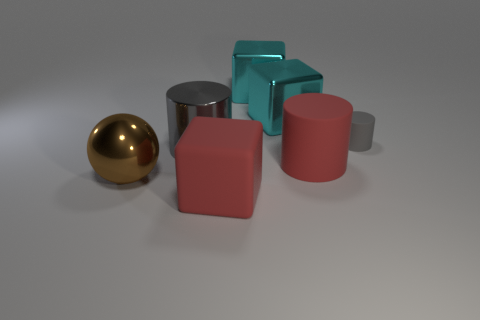Subtract 1 cylinders. How many cylinders are left? 2 Subtract all red balls. How many cyan blocks are left? 2 Subtract all big metal blocks. How many blocks are left? 1 Add 1 small cyan metallic spheres. How many objects exist? 8 Subtract all purple cylinders. Subtract all green balls. How many cylinders are left? 3 Subtract all spheres. How many objects are left? 6 Subtract all big gray cylinders. Subtract all large things. How many objects are left? 0 Add 2 brown shiny spheres. How many brown shiny spheres are left? 3 Add 1 small yellow metal spheres. How many small yellow metal spheres exist? 1 Subtract 1 red cylinders. How many objects are left? 6 